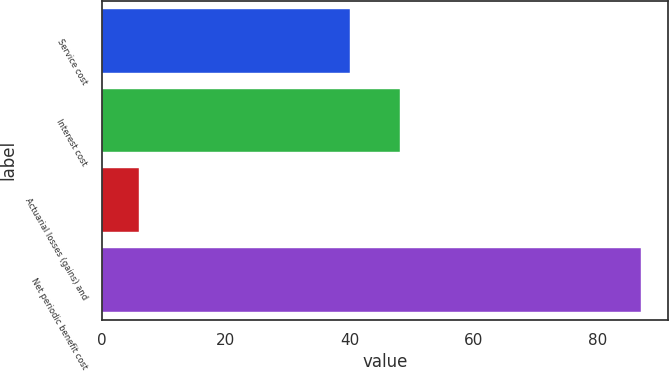<chart> <loc_0><loc_0><loc_500><loc_500><bar_chart><fcel>Service cost<fcel>Interest cost<fcel>Actuarial losses (gains) and<fcel>Net periodic benefit cost<nl><fcel>40<fcel>48.1<fcel>6<fcel>87<nl></chart> 